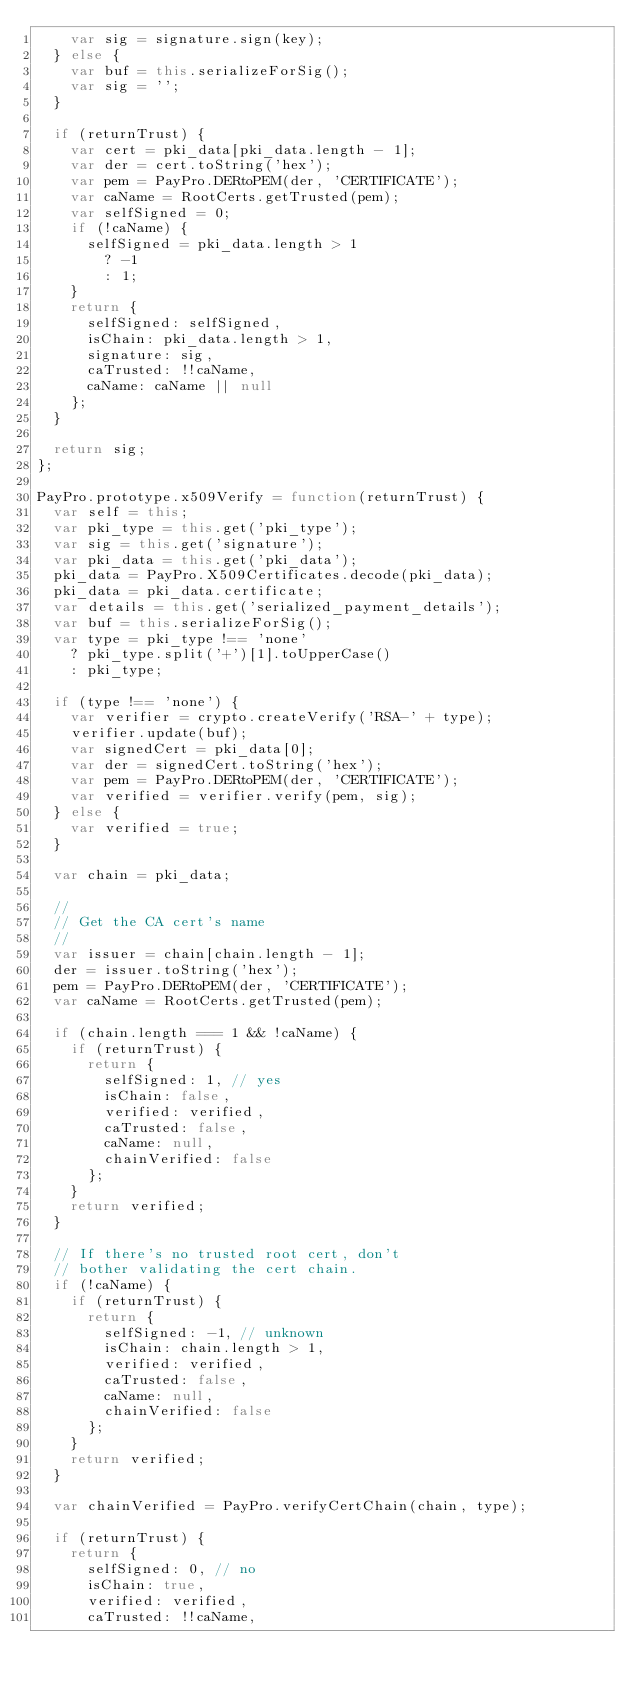<code> <loc_0><loc_0><loc_500><loc_500><_JavaScript_>    var sig = signature.sign(key);
  } else {
    var buf = this.serializeForSig();
    var sig = '';
  }

  if (returnTrust) {
    var cert = pki_data[pki_data.length - 1];
    var der = cert.toString('hex');
    var pem = PayPro.DERtoPEM(der, 'CERTIFICATE');
    var caName = RootCerts.getTrusted(pem);
    var selfSigned = 0;
    if (!caName) {
      selfSigned = pki_data.length > 1
        ? -1
        : 1;
    }
    return {
      selfSigned: selfSigned,
      isChain: pki_data.length > 1,
      signature: sig,
      caTrusted: !!caName,
      caName: caName || null
    };
  }

  return sig;
};

PayPro.prototype.x509Verify = function(returnTrust) {
  var self = this;
  var pki_type = this.get('pki_type');
  var sig = this.get('signature');
  var pki_data = this.get('pki_data');
  pki_data = PayPro.X509Certificates.decode(pki_data);
  pki_data = pki_data.certificate;
  var details = this.get('serialized_payment_details');
  var buf = this.serializeForSig();
  var type = pki_type !== 'none'
    ? pki_type.split('+')[1].toUpperCase()
    : pki_type;

  if (type !== 'none') {
    var verifier = crypto.createVerify('RSA-' + type);
    verifier.update(buf);
    var signedCert = pki_data[0];
    var der = signedCert.toString('hex');
    var pem = PayPro.DERtoPEM(der, 'CERTIFICATE');
    var verified = verifier.verify(pem, sig);
  } else {
    var verified = true;
  }

  var chain = pki_data;

  //
  // Get the CA cert's name
  //
  var issuer = chain[chain.length - 1];
  der = issuer.toString('hex');
  pem = PayPro.DERtoPEM(der, 'CERTIFICATE');
  var caName = RootCerts.getTrusted(pem);

  if (chain.length === 1 && !caName) {
    if (returnTrust) {
      return {
        selfSigned: 1, // yes
        isChain: false,
        verified: verified,
        caTrusted: false,
        caName: null,
        chainVerified: false
      };
    }
    return verified;
  }

  // If there's no trusted root cert, don't
  // bother validating the cert chain.
  if (!caName) {
    if (returnTrust) {
      return {
        selfSigned: -1, // unknown
        isChain: chain.length > 1,
        verified: verified,
        caTrusted: false,
        caName: null,
        chainVerified: false
      };
    }
    return verified;
  }

  var chainVerified = PayPro.verifyCertChain(chain, type);

  if (returnTrust) {
    return {
      selfSigned: 0, // no
      isChain: true,
      verified: verified,
      caTrusted: !!caName,</code> 